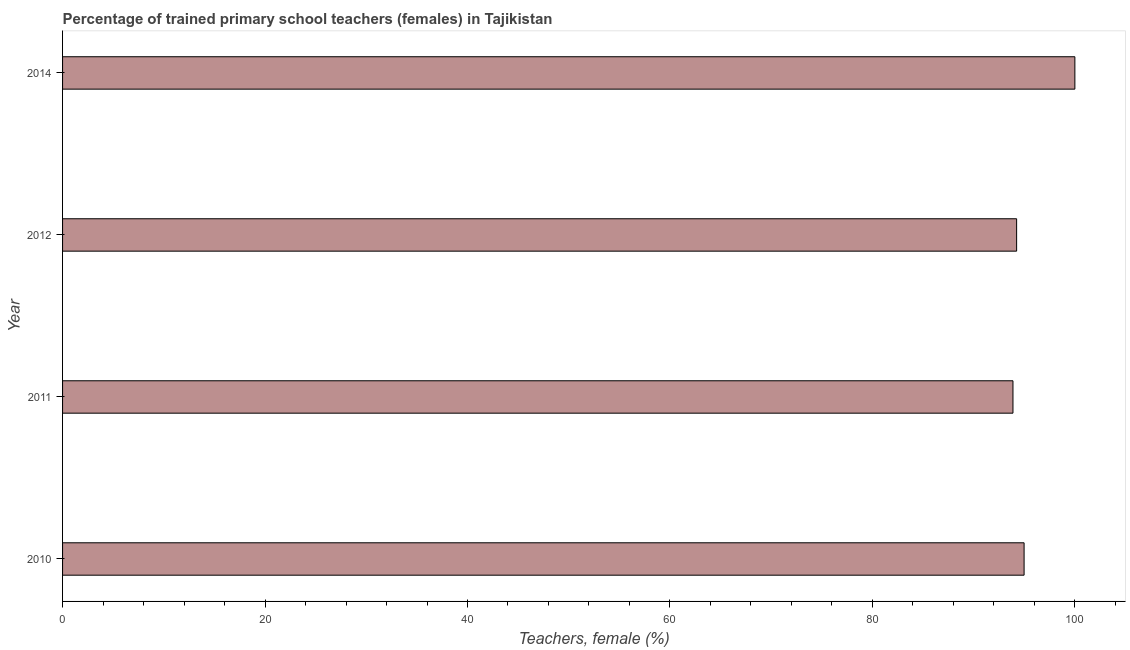What is the title of the graph?
Provide a short and direct response. Percentage of trained primary school teachers (females) in Tajikistan. What is the label or title of the X-axis?
Give a very brief answer. Teachers, female (%). What is the label or title of the Y-axis?
Ensure brevity in your answer.  Year. What is the percentage of trained female teachers in 2012?
Make the answer very short. 94.24. Across all years, what is the minimum percentage of trained female teachers?
Offer a very short reply. 93.88. In which year was the percentage of trained female teachers minimum?
Your response must be concise. 2011. What is the sum of the percentage of trained female teachers?
Give a very brief answer. 383.11. What is the difference between the percentage of trained female teachers in 2010 and 2011?
Provide a succinct answer. 1.1. What is the average percentage of trained female teachers per year?
Your answer should be very brief. 95.78. What is the median percentage of trained female teachers?
Offer a very short reply. 94.61. In how many years, is the percentage of trained female teachers greater than 4 %?
Give a very brief answer. 4. Do a majority of the years between 2014 and 2012 (inclusive) have percentage of trained female teachers greater than 76 %?
Your answer should be very brief. No. Is the percentage of trained female teachers in 2012 less than that in 2014?
Provide a short and direct response. Yes. Is the difference between the percentage of trained female teachers in 2010 and 2014 greater than the difference between any two years?
Your answer should be compact. No. What is the difference between the highest and the second highest percentage of trained female teachers?
Provide a succinct answer. 5.02. Is the sum of the percentage of trained female teachers in 2010 and 2011 greater than the maximum percentage of trained female teachers across all years?
Your answer should be compact. Yes. What is the difference between the highest and the lowest percentage of trained female teachers?
Your answer should be compact. 6.12. In how many years, is the percentage of trained female teachers greater than the average percentage of trained female teachers taken over all years?
Offer a very short reply. 1. How many bars are there?
Ensure brevity in your answer.  4. Are all the bars in the graph horizontal?
Ensure brevity in your answer.  Yes. How many years are there in the graph?
Your answer should be very brief. 4. Are the values on the major ticks of X-axis written in scientific E-notation?
Your answer should be very brief. No. What is the Teachers, female (%) in 2010?
Your answer should be compact. 94.98. What is the Teachers, female (%) of 2011?
Your response must be concise. 93.88. What is the Teachers, female (%) of 2012?
Offer a terse response. 94.24. What is the Teachers, female (%) of 2014?
Provide a succinct answer. 100. What is the difference between the Teachers, female (%) in 2010 and 2011?
Ensure brevity in your answer.  1.1. What is the difference between the Teachers, female (%) in 2010 and 2012?
Ensure brevity in your answer.  0.74. What is the difference between the Teachers, female (%) in 2010 and 2014?
Your answer should be very brief. -5.02. What is the difference between the Teachers, female (%) in 2011 and 2012?
Offer a terse response. -0.36. What is the difference between the Teachers, female (%) in 2011 and 2014?
Your answer should be compact. -6.12. What is the difference between the Teachers, female (%) in 2012 and 2014?
Provide a short and direct response. -5.76. What is the ratio of the Teachers, female (%) in 2010 to that in 2014?
Keep it short and to the point. 0.95. What is the ratio of the Teachers, female (%) in 2011 to that in 2014?
Make the answer very short. 0.94. What is the ratio of the Teachers, female (%) in 2012 to that in 2014?
Your answer should be compact. 0.94. 